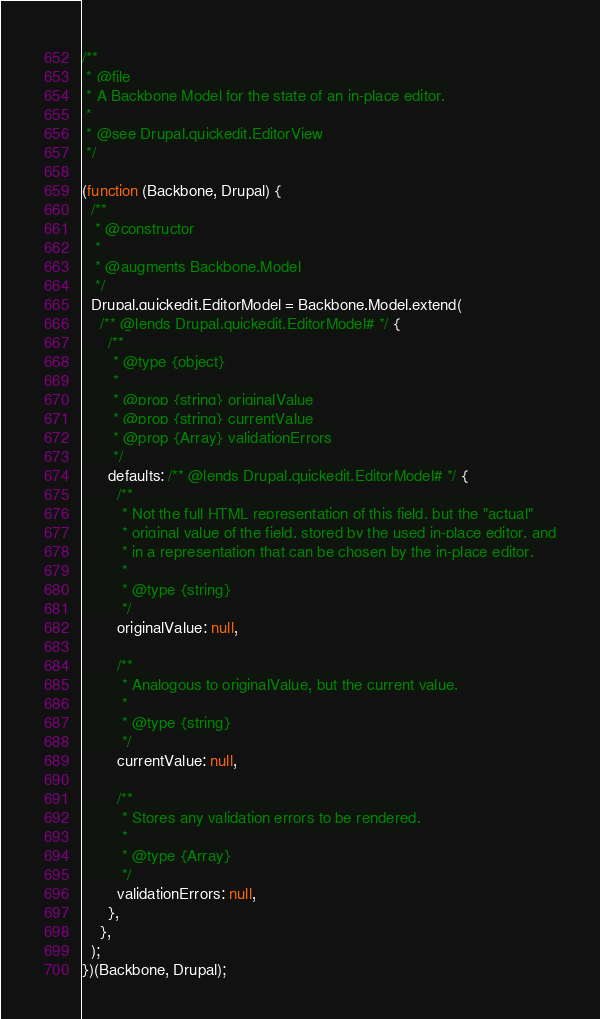Convert code to text. <code><loc_0><loc_0><loc_500><loc_500><_JavaScript_>/**
 * @file
 * A Backbone Model for the state of an in-place editor.
 *
 * @see Drupal.quickedit.EditorView
 */

(function (Backbone, Drupal) {
  /**
   * @constructor
   *
   * @augments Backbone.Model
   */
  Drupal.quickedit.EditorModel = Backbone.Model.extend(
    /** @lends Drupal.quickedit.EditorModel# */ {
      /**
       * @type {object}
       *
       * @prop {string} originalValue
       * @prop {string} currentValue
       * @prop {Array} validationErrors
       */
      defaults: /** @lends Drupal.quickedit.EditorModel# */ {
        /**
         * Not the full HTML representation of this field, but the "actual"
         * original value of the field, stored by the used in-place editor, and
         * in a representation that can be chosen by the in-place editor.
         *
         * @type {string}
         */
        originalValue: null,

        /**
         * Analogous to originalValue, but the current value.
         *
         * @type {string}
         */
        currentValue: null,

        /**
         * Stores any validation errors to be rendered.
         *
         * @type {Array}
         */
        validationErrors: null,
      },
    },
  );
})(Backbone, Drupal);
</code> 